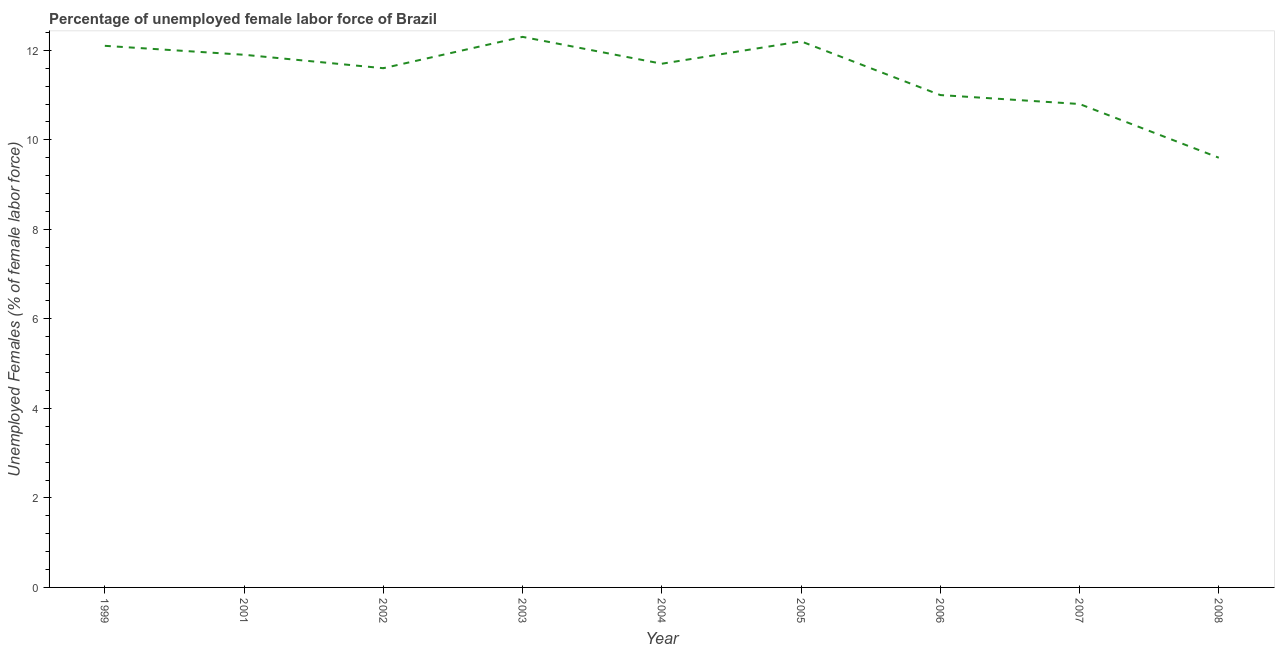What is the total unemployed female labour force in 1999?
Keep it short and to the point. 12.1. Across all years, what is the maximum total unemployed female labour force?
Keep it short and to the point. 12.3. Across all years, what is the minimum total unemployed female labour force?
Offer a terse response. 9.6. In which year was the total unemployed female labour force maximum?
Keep it short and to the point. 2003. What is the sum of the total unemployed female labour force?
Make the answer very short. 103.2. What is the difference between the total unemployed female labour force in 1999 and 2007?
Make the answer very short. 1.3. What is the average total unemployed female labour force per year?
Ensure brevity in your answer.  11.47. What is the median total unemployed female labour force?
Provide a succinct answer. 11.7. What is the ratio of the total unemployed female labour force in 1999 to that in 2001?
Make the answer very short. 1.02. Is the difference between the total unemployed female labour force in 2004 and 2005 greater than the difference between any two years?
Your response must be concise. No. What is the difference between the highest and the second highest total unemployed female labour force?
Your answer should be very brief. 0.1. Is the sum of the total unemployed female labour force in 2004 and 2008 greater than the maximum total unemployed female labour force across all years?
Your answer should be compact. Yes. What is the difference between the highest and the lowest total unemployed female labour force?
Offer a very short reply. 2.7. Does the total unemployed female labour force monotonically increase over the years?
Your answer should be compact. No. How many lines are there?
Offer a very short reply. 1. What is the title of the graph?
Keep it short and to the point. Percentage of unemployed female labor force of Brazil. What is the label or title of the X-axis?
Your answer should be compact. Year. What is the label or title of the Y-axis?
Provide a short and direct response. Unemployed Females (% of female labor force). What is the Unemployed Females (% of female labor force) in 1999?
Give a very brief answer. 12.1. What is the Unemployed Females (% of female labor force) in 2001?
Your response must be concise. 11.9. What is the Unemployed Females (% of female labor force) of 2002?
Your answer should be compact. 11.6. What is the Unemployed Females (% of female labor force) in 2003?
Keep it short and to the point. 12.3. What is the Unemployed Females (% of female labor force) in 2004?
Provide a short and direct response. 11.7. What is the Unemployed Females (% of female labor force) in 2005?
Give a very brief answer. 12.2. What is the Unemployed Females (% of female labor force) of 2006?
Give a very brief answer. 11. What is the Unemployed Females (% of female labor force) in 2007?
Provide a succinct answer. 10.8. What is the Unemployed Females (% of female labor force) in 2008?
Your response must be concise. 9.6. What is the difference between the Unemployed Females (% of female labor force) in 1999 and 2001?
Make the answer very short. 0.2. What is the difference between the Unemployed Females (% of female labor force) in 1999 and 2002?
Offer a very short reply. 0.5. What is the difference between the Unemployed Females (% of female labor force) in 1999 and 2003?
Provide a short and direct response. -0.2. What is the difference between the Unemployed Females (% of female labor force) in 1999 and 2004?
Provide a succinct answer. 0.4. What is the difference between the Unemployed Females (% of female labor force) in 1999 and 2005?
Ensure brevity in your answer.  -0.1. What is the difference between the Unemployed Females (% of female labor force) in 1999 and 2006?
Offer a very short reply. 1.1. What is the difference between the Unemployed Females (% of female labor force) in 1999 and 2007?
Ensure brevity in your answer.  1.3. What is the difference between the Unemployed Females (% of female labor force) in 1999 and 2008?
Keep it short and to the point. 2.5. What is the difference between the Unemployed Females (% of female labor force) in 2001 and 2008?
Your answer should be compact. 2.3. What is the difference between the Unemployed Females (% of female labor force) in 2002 and 2004?
Your response must be concise. -0.1. What is the difference between the Unemployed Females (% of female labor force) in 2002 and 2008?
Keep it short and to the point. 2. What is the difference between the Unemployed Females (% of female labor force) in 2003 and 2006?
Offer a very short reply. 1.3. What is the difference between the Unemployed Females (% of female labor force) in 2003 and 2007?
Ensure brevity in your answer.  1.5. What is the difference between the Unemployed Females (% of female labor force) in 2004 and 2006?
Keep it short and to the point. 0.7. What is the difference between the Unemployed Females (% of female labor force) in 2005 and 2006?
Your answer should be compact. 1.2. What is the difference between the Unemployed Females (% of female labor force) in 2005 and 2007?
Offer a very short reply. 1.4. What is the difference between the Unemployed Females (% of female labor force) in 2006 and 2007?
Make the answer very short. 0.2. What is the difference between the Unemployed Females (% of female labor force) in 2006 and 2008?
Provide a short and direct response. 1.4. What is the ratio of the Unemployed Females (% of female labor force) in 1999 to that in 2002?
Provide a short and direct response. 1.04. What is the ratio of the Unemployed Females (% of female labor force) in 1999 to that in 2004?
Your response must be concise. 1.03. What is the ratio of the Unemployed Females (% of female labor force) in 1999 to that in 2005?
Your response must be concise. 0.99. What is the ratio of the Unemployed Females (% of female labor force) in 1999 to that in 2007?
Your answer should be compact. 1.12. What is the ratio of the Unemployed Females (% of female labor force) in 1999 to that in 2008?
Your answer should be compact. 1.26. What is the ratio of the Unemployed Females (% of female labor force) in 2001 to that in 2002?
Keep it short and to the point. 1.03. What is the ratio of the Unemployed Females (% of female labor force) in 2001 to that in 2003?
Provide a succinct answer. 0.97. What is the ratio of the Unemployed Females (% of female labor force) in 2001 to that in 2004?
Offer a very short reply. 1.02. What is the ratio of the Unemployed Females (% of female labor force) in 2001 to that in 2005?
Offer a terse response. 0.97. What is the ratio of the Unemployed Females (% of female labor force) in 2001 to that in 2006?
Your response must be concise. 1.08. What is the ratio of the Unemployed Females (% of female labor force) in 2001 to that in 2007?
Keep it short and to the point. 1.1. What is the ratio of the Unemployed Females (% of female labor force) in 2001 to that in 2008?
Offer a very short reply. 1.24. What is the ratio of the Unemployed Females (% of female labor force) in 2002 to that in 2003?
Provide a short and direct response. 0.94. What is the ratio of the Unemployed Females (% of female labor force) in 2002 to that in 2005?
Your answer should be compact. 0.95. What is the ratio of the Unemployed Females (% of female labor force) in 2002 to that in 2006?
Provide a succinct answer. 1.05. What is the ratio of the Unemployed Females (% of female labor force) in 2002 to that in 2007?
Give a very brief answer. 1.07. What is the ratio of the Unemployed Females (% of female labor force) in 2002 to that in 2008?
Offer a very short reply. 1.21. What is the ratio of the Unemployed Females (% of female labor force) in 2003 to that in 2004?
Provide a succinct answer. 1.05. What is the ratio of the Unemployed Females (% of female labor force) in 2003 to that in 2005?
Your response must be concise. 1.01. What is the ratio of the Unemployed Females (% of female labor force) in 2003 to that in 2006?
Give a very brief answer. 1.12. What is the ratio of the Unemployed Females (% of female labor force) in 2003 to that in 2007?
Give a very brief answer. 1.14. What is the ratio of the Unemployed Females (% of female labor force) in 2003 to that in 2008?
Provide a short and direct response. 1.28. What is the ratio of the Unemployed Females (% of female labor force) in 2004 to that in 2005?
Your response must be concise. 0.96. What is the ratio of the Unemployed Females (% of female labor force) in 2004 to that in 2006?
Your answer should be very brief. 1.06. What is the ratio of the Unemployed Females (% of female labor force) in 2004 to that in 2007?
Provide a short and direct response. 1.08. What is the ratio of the Unemployed Females (% of female labor force) in 2004 to that in 2008?
Offer a terse response. 1.22. What is the ratio of the Unemployed Females (% of female labor force) in 2005 to that in 2006?
Give a very brief answer. 1.11. What is the ratio of the Unemployed Females (% of female labor force) in 2005 to that in 2007?
Provide a succinct answer. 1.13. What is the ratio of the Unemployed Females (% of female labor force) in 2005 to that in 2008?
Offer a very short reply. 1.27. What is the ratio of the Unemployed Females (% of female labor force) in 2006 to that in 2008?
Offer a terse response. 1.15. What is the ratio of the Unemployed Females (% of female labor force) in 2007 to that in 2008?
Offer a terse response. 1.12. 